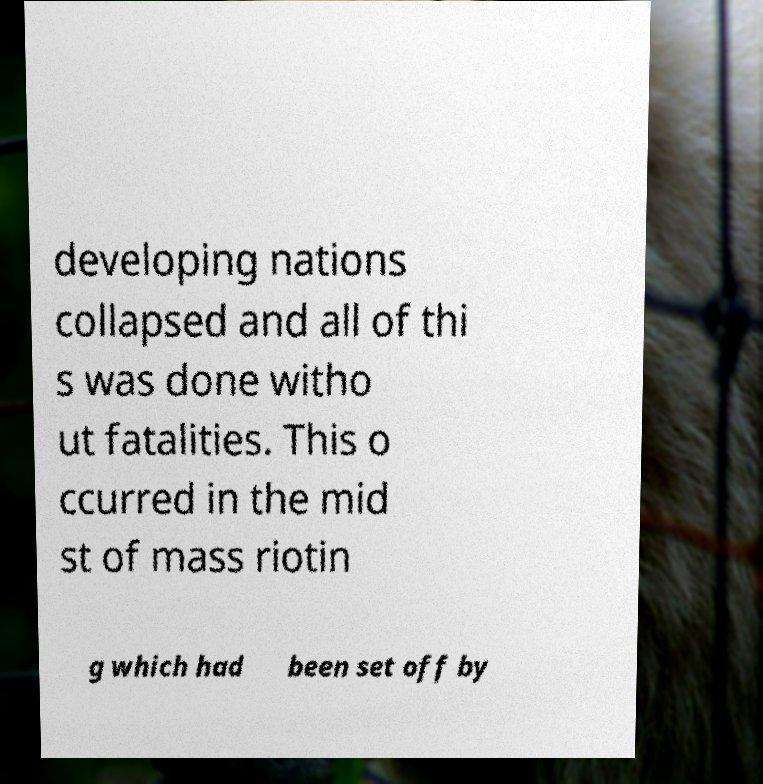There's text embedded in this image that I need extracted. Can you transcribe it verbatim? developing nations collapsed and all of thi s was done witho ut fatalities. This o ccurred in the mid st of mass riotin g which had been set off by 